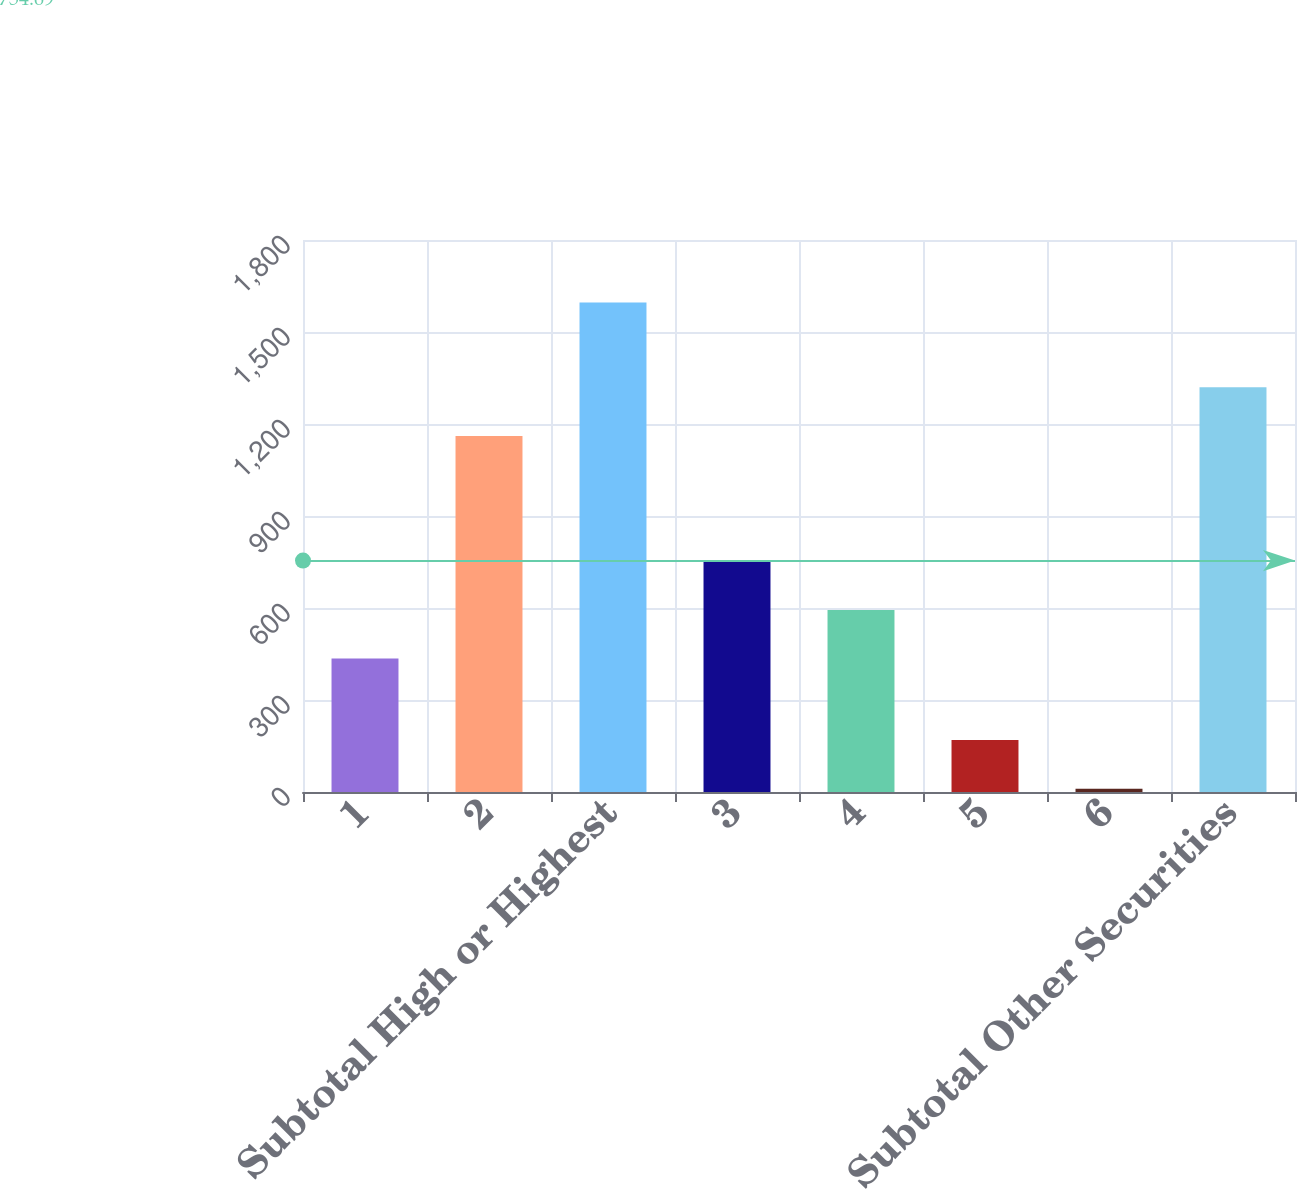Convert chart to OTSL. <chart><loc_0><loc_0><loc_500><loc_500><bar_chart><fcel>1<fcel>2<fcel>Subtotal High or Highest<fcel>3<fcel>4<fcel>5<fcel>6<fcel>Subtotal Other Securities<nl><fcel>435<fcel>1161<fcel>1596<fcel>752<fcel>593.5<fcel>169.5<fcel>11<fcel>1319.5<nl></chart> 